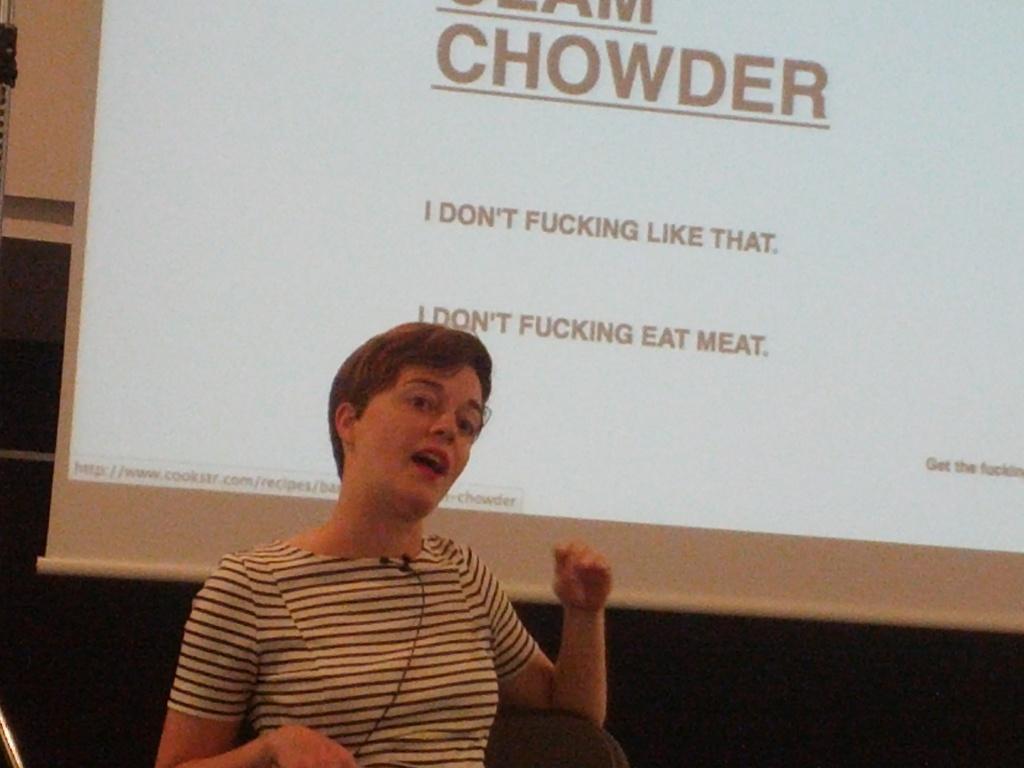In one or two sentences, can you explain what this image depicts? Here is a person sitting on the chair and speaking. This looks like a screen with a display. 